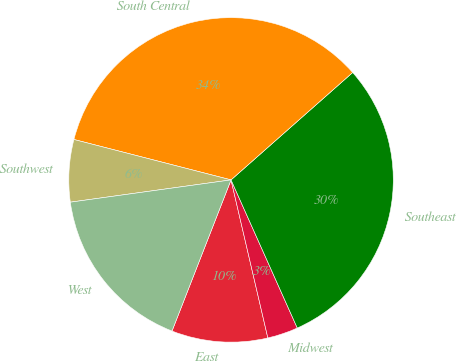Convert chart to OTSL. <chart><loc_0><loc_0><loc_500><loc_500><pie_chart><fcel>East<fcel>Midwest<fcel>Southeast<fcel>South Central<fcel>Southwest<fcel>West<nl><fcel>9.57%<fcel>3.05%<fcel>29.82%<fcel>34.48%<fcel>6.2%<fcel>16.88%<nl></chart> 